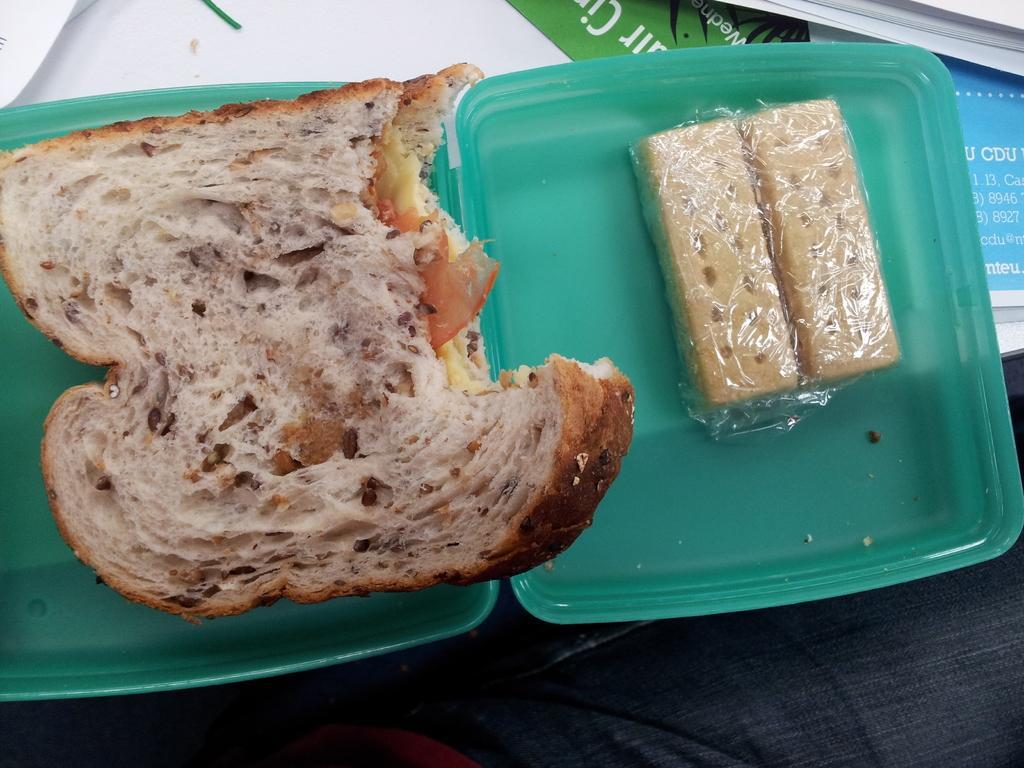In one or two sentences, can you explain what this image depicts? In this image, we can see food in the box and we can see some papers. 